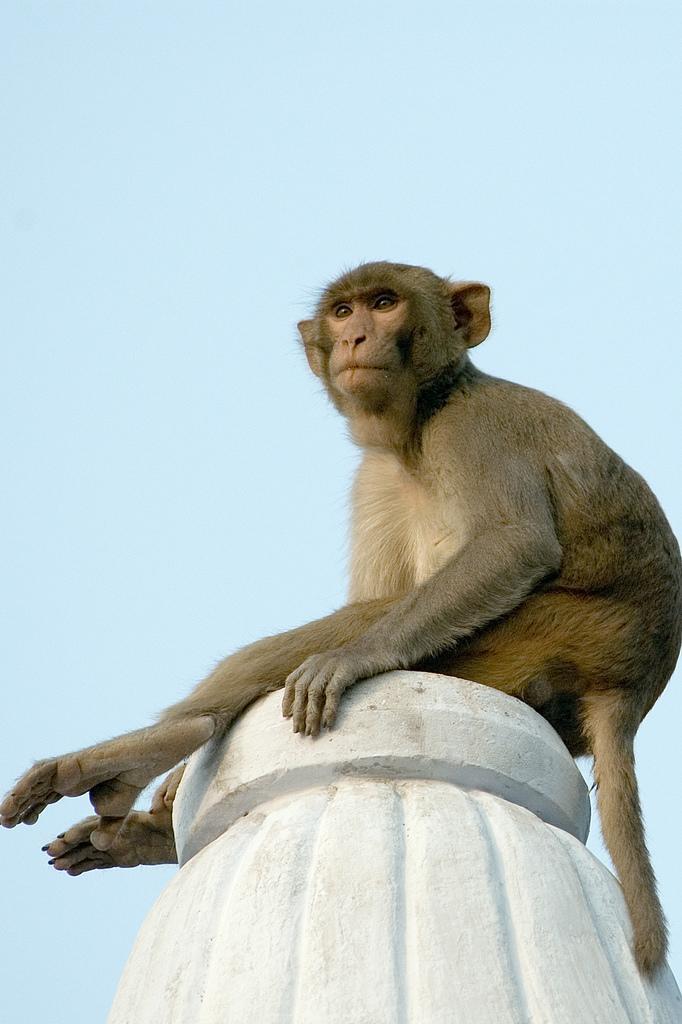Can you describe this image briefly? In this image there is a monkey on the rock structure. In the background there is the sky. 